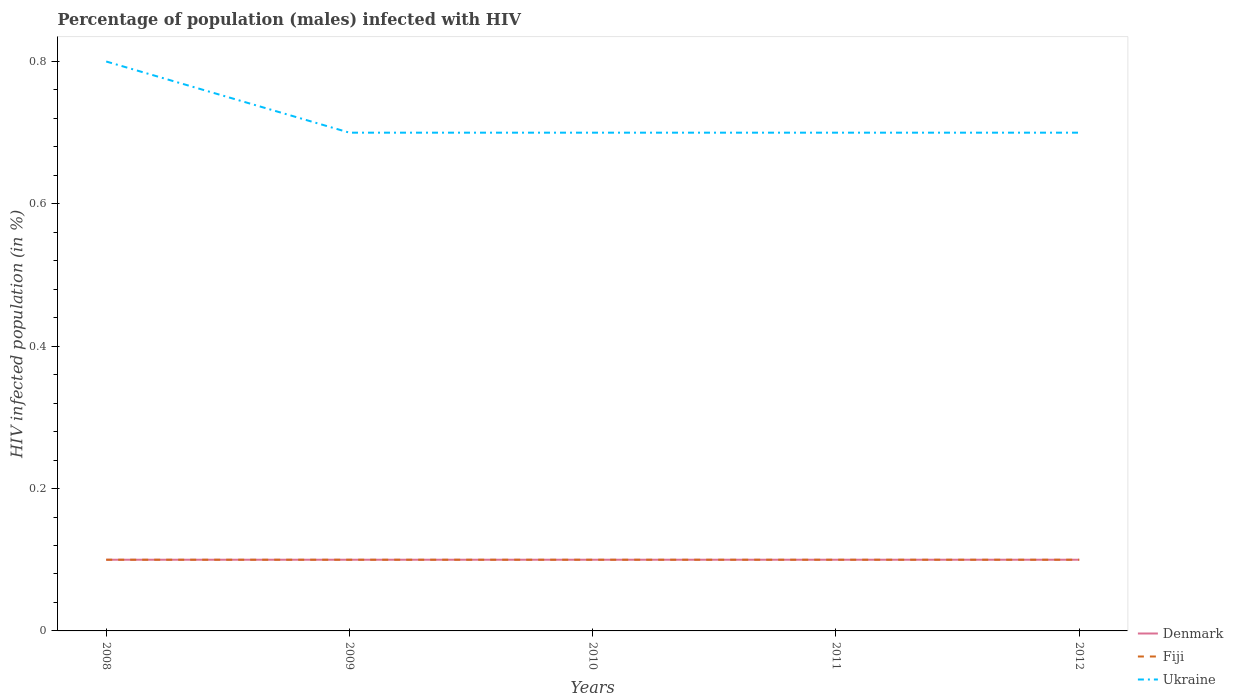Is the number of lines equal to the number of legend labels?
Provide a short and direct response. Yes. Across all years, what is the maximum percentage of HIV infected male population in Denmark?
Offer a very short reply. 0.1. In which year was the percentage of HIV infected male population in Fiji maximum?
Make the answer very short. 2008. What is the difference between the highest and the lowest percentage of HIV infected male population in Fiji?
Provide a succinct answer. 0. Is the percentage of HIV infected male population in Denmark strictly greater than the percentage of HIV infected male population in Ukraine over the years?
Provide a short and direct response. Yes. How many lines are there?
Ensure brevity in your answer.  3. How many years are there in the graph?
Give a very brief answer. 5. What is the difference between two consecutive major ticks on the Y-axis?
Offer a terse response. 0.2. Are the values on the major ticks of Y-axis written in scientific E-notation?
Offer a terse response. No. Does the graph contain grids?
Your answer should be very brief. No. How are the legend labels stacked?
Offer a very short reply. Vertical. What is the title of the graph?
Your response must be concise. Percentage of population (males) infected with HIV. Does "Mexico" appear as one of the legend labels in the graph?
Offer a very short reply. No. What is the label or title of the Y-axis?
Offer a very short reply. HIV infected population (in %). What is the HIV infected population (in %) of Fiji in 2008?
Provide a succinct answer. 0.1. What is the HIV infected population (in %) in Ukraine in 2008?
Your answer should be very brief. 0.8. What is the HIV infected population (in %) of Denmark in 2009?
Keep it short and to the point. 0.1. What is the HIV infected population (in %) of Fiji in 2009?
Your answer should be compact. 0.1. What is the HIV infected population (in %) of Fiji in 2010?
Provide a succinct answer. 0.1. What is the HIV infected population (in %) in Ukraine in 2010?
Ensure brevity in your answer.  0.7. What is the HIV infected population (in %) in Ukraine in 2011?
Your answer should be compact. 0.7. What is the HIV infected population (in %) in Denmark in 2012?
Keep it short and to the point. 0.1. What is the HIV infected population (in %) in Ukraine in 2012?
Your response must be concise. 0.7. Across all years, what is the maximum HIV infected population (in %) in Fiji?
Keep it short and to the point. 0.1. Across all years, what is the minimum HIV infected population (in %) in Fiji?
Offer a very short reply. 0.1. What is the total HIV infected population (in %) in Denmark in the graph?
Give a very brief answer. 0.5. What is the total HIV infected population (in %) of Ukraine in the graph?
Offer a very short reply. 3.6. What is the difference between the HIV infected population (in %) in Denmark in 2008 and that in 2010?
Offer a very short reply. 0. What is the difference between the HIV infected population (in %) of Fiji in 2008 and that in 2010?
Keep it short and to the point. 0. What is the difference between the HIV infected population (in %) of Ukraine in 2008 and that in 2010?
Give a very brief answer. 0.1. What is the difference between the HIV infected population (in %) in Denmark in 2008 and that in 2011?
Offer a terse response. 0. What is the difference between the HIV infected population (in %) in Fiji in 2008 and that in 2011?
Ensure brevity in your answer.  0. What is the difference between the HIV infected population (in %) in Denmark in 2009 and that in 2011?
Provide a short and direct response. 0. What is the difference between the HIV infected population (in %) in Fiji in 2009 and that in 2012?
Provide a short and direct response. 0. What is the difference between the HIV infected population (in %) in Ukraine in 2010 and that in 2011?
Your answer should be very brief. 0. What is the difference between the HIV infected population (in %) of Denmark in 2010 and that in 2012?
Offer a very short reply. 0. What is the difference between the HIV infected population (in %) of Denmark in 2008 and the HIV infected population (in %) of Ukraine in 2009?
Your response must be concise. -0.6. What is the difference between the HIV infected population (in %) of Denmark in 2008 and the HIV infected population (in %) of Fiji in 2010?
Provide a succinct answer. 0. What is the difference between the HIV infected population (in %) of Denmark in 2008 and the HIV infected population (in %) of Ukraine in 2010?
Your response must be concise. -0.6. What is the difference between the HIV infected population (in %) of Fiji in 2008 and the HIV infected population (in %) of Ukraine in 2010?
Your answer should be very brief. -0.6. What is the difference between the HIV infected population (in %) of Fiji in 2008 and the HIV infected population (in %) of Ukraine in 2011?
Keep it short and to the point. -0.6. What is the difference between the HIV infected population (in %) of Denmark in 2008 and the HIV infected population (in %) of Fiji in 2012?
Give a very brief answer. 0. What is the difference between the HIV infected population (in %) of Denmark in 2008 and the HIV infected population (in %) of Ukraine in 2012?
Ensure brevity in your answer.  -0.6. What is the difference between the HIV infected population (in %) of Denmark in 2009 and the HIV infected population (in %) of Fiji in 2012?
Provide a short and direct response. 0. What is the difference between the HIV infected population (in %) of Fiji in 2009 and the HIV infected population (in %) of Ukraine in 2012?
Offer a terse response. -0.6. What is the difference between the HIV infected population (in %) of Fiji in 2010 and the HIV infected population (in %) of Ukraine in 2011?
Make the answer very short. -0.6. What is the difference between the HIV infected population (in %) of Denmark in 2010 and the HIV infected population (in %) of Ukraine in 2012?
Keep it short and to the point. -0.6. What is the difference between the HIV infected population (in %) in Denmark in 2011 and the HIV infected population (in %) in Ukraine in 2012?
Ensure brevity in your answer.  -0.6. What is the difference between the HIV infected population (in %) in Fiji in 2011 and the HIV infected population (in %) in Ukraine in 2012?
Provide a succinct answer. -0.6. What is the average HIV infected population (in %) of Denmark per year?
Ensure brevity in your answer.  0.1. What is the average HIV infected population (in %) in Ukraine per year?
Give a very brief answer. 0.72. In the year 2008, what is the difference between the HIV infected population (in %) in Fiji and HIV infected population (in %) in Ukraine?
Make the answer very short. -0.7. In the year 2009, what is the difference between the HIV infected population (in %) of Denmark and HIV infected population (in %) of Fiji?
Ensure brevity in your answer.  0. In the year 2009, what is the difference between the HIV infected population (in %) of Fiji and HIV infected population (in %) of Ukraine?
Provide a succinct answer. -0.6. In the year 2010, what is the difference between the HIV infected population (in %) in Denmark and HIV infected population (in %) in Fiji?
Make the answer very short. 0. In the year 2011, what is the difference between the HIV infected population (in %) of Denmark and HIV infected population (in %) of Ukraine?
Ensure brevity in your answer.  -0.6. In the year 2011, what is the difference between the HIV infected population (in %) in Fiji and HIV infected population (in %) in Ukraine?
Offer a very short reply. -0.6. In the year 2012, what is the difference between the HIV infected population (in %) in Fiji and HIV infected population (in %) in Ukraine?
Make the answer very short. -0.6. What is the ratio of the HIV infected population (in %) in Fiji in 2008 to that in 2009?
Your answer should be compact. 1. What is the ratio of the HIV infected population (in %) of Fiji in 2008 to that in 2010?
Provide a short and direct response. 1. What is the ratio of the HIV infected population (in %) of Ukraine in 2008 to that in 2010?
Provide a short and direct response. 1.14. What is the ratio of the HIV infected population (in %) of Denmark in 2008 to that in 2011?
Provide a short and direct response. 1. What is the ratio of the HIV infected population (in %) of Ukraine in 2008 to that in 2011?
Your response must be concise. 1.14. What is the ratio of the HIV infected population (in %) of Fiji in 2008 to that in 2012?
Ensure brevity in your answer.  1. What is the ratio of the HIV infected population (in %) of Ukraine in 2008 to that in 2012?
Your answer should be compact. 1.14. What is the ratio of the HIV infected population (in %) of Fiji in 2009 to that in 2010?
Keep it short and to the point. 1. What is the ratio of the HIV infected population (in %) of Fiji in 2009 to that in 2011?
Offer a terse response. 1. What is the ratio of the HIV infected population (in %) in Ukraine in 2009 to that in 2011?
Give a very brief answer. 1. What is the ratio of the HIV infected population (in %) in Fiji in 2010 to that in 2011?
Make the answer very short. 1. What is the ratio of the HIV infected population (in %) of Fiji in 2010 to that in 2012?
Your response must be concise. 1. What is the ratio of the HIV infected population (in %) of Denmark in 2011 to that in 2012?
Offer a terse response. 1. What is the ratio of the HIV infected population (in %) in Fiji in 2011 to that in 2012?
Offer a terse response. 1. What is the difference between the highest and the second highest HIV infected population (in %) of Ukraine?
Offer a very short reply. 0.1. What is the difference between the highest and the lowest HIV infected population (in %) of Fiji?
Your response must be concise. 0. What is the difference between the highest and the lowest HIV infected population (in %) in Ukraine?
Offer a terse response. 0.1. 